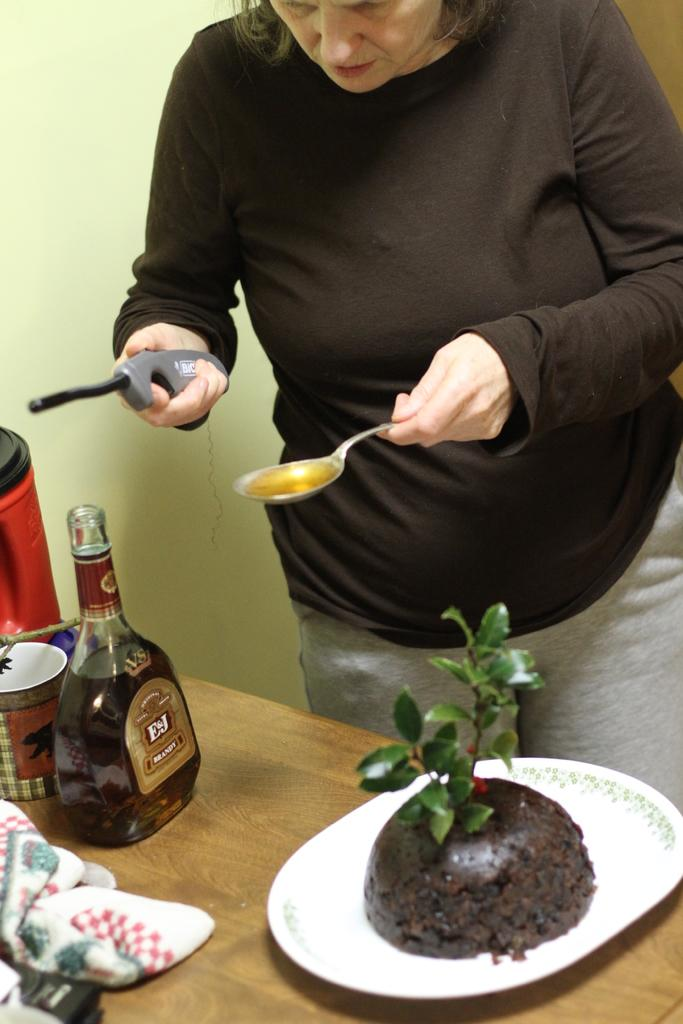Who is present in the image? There is a woman in the image. What is the woman doing in the image? The woman is standing. What can be seen behind the woman in the image? There is a yellow wall in the image. What is in front of the woman in the image? There is a table in front of the woman. What objects are on the table in the image? There is a plant, a plate, a bottle, and a glass on the table. Where is the rake being used in the image? There is no rake present in the image. What type of nest can be seen on the table in the image? There is no nest present on the table in the image. 